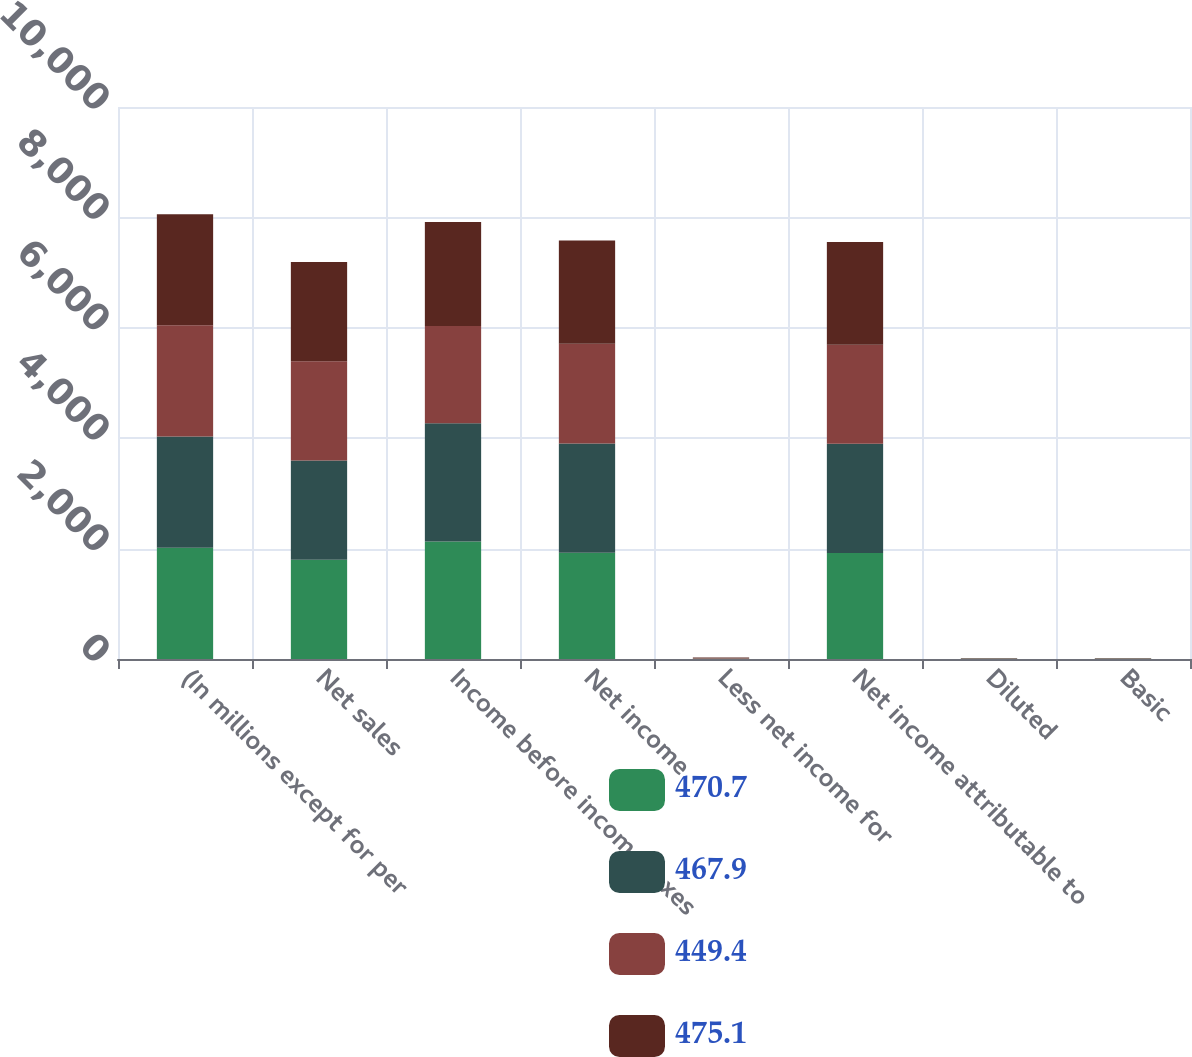<chart> <loc_0><loc_0><loc_500><loc_500><stacked_bar_chart><ecel><fcel>(In millions except for per<fcel>Net sales<fcel>Income before income taxes<fcel>Net income<fcel>Less net income for<fcel>Net income attributable to<fcel>Diluted<fcel>Basic<nl><fcel>470.7<fcel>2016<fcel>1798<fcel>2127<fcel>1925<fcel>3<fcel>1922<fcel>4.21<fcel>4.22<nl><fcel>467.9<fcel>2015<fcel>1798<fcel>2145<fcel>1981<fcel>2<fcel>1979<fcel>4.23<fcel>4.25<nl><fcel>449.4<fcel>2014<fcel>1798<fcel>1761<fcel>1803<fcel>10<fcel>1793<fcel>3.76<fcel>3.78<nl><fcel>475.1<fcel>2013<fcel>1798<fcel>1884<fcel>1873<fcel>12<fcel>1861<fcel>3.9<fcel>3.93<nl></chart> 